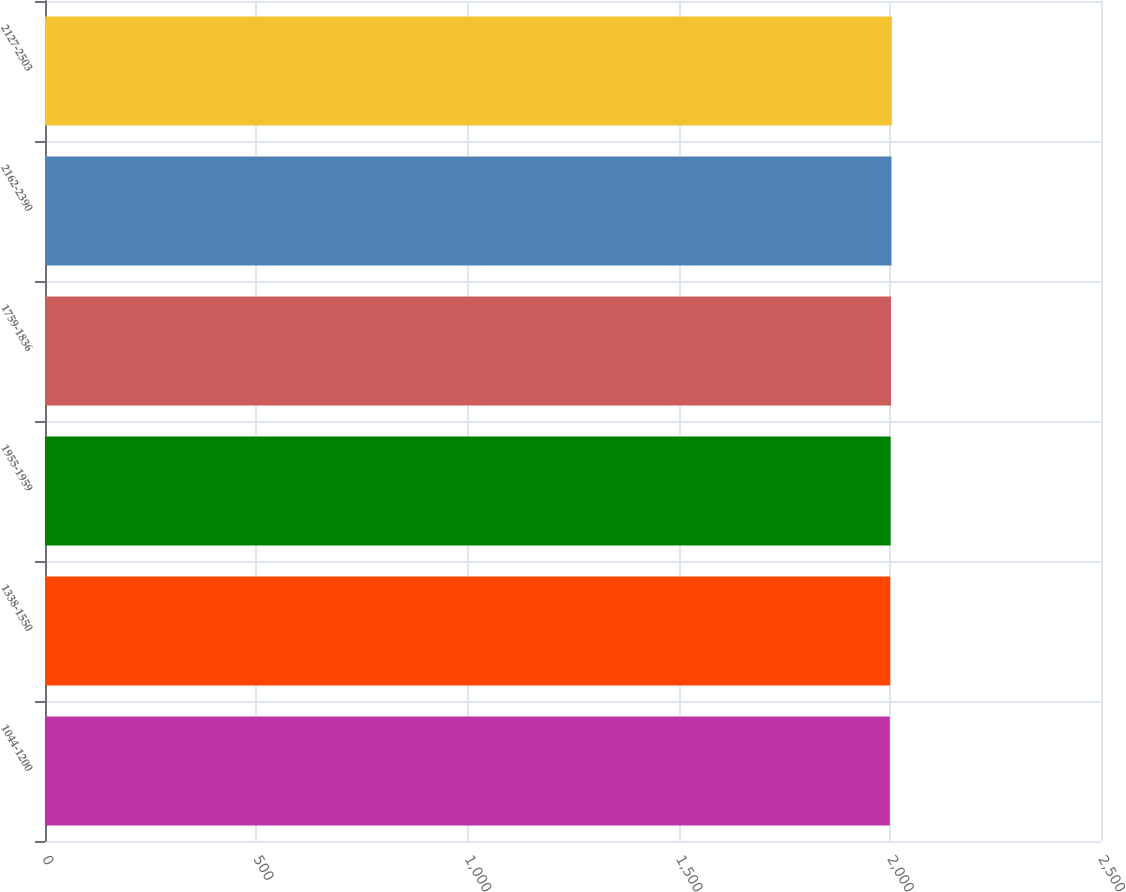Convert chart. <chart><loc_0><loc_0><loc_500><loc_500><bar_chart><fcel>1044-1200<fcel>1338-1550<fcel>1955-1959<fcel>1759-1836<fcel>2162-2390<fcel>2127-2503<nl><fcel>2000<fcel>2001<fcel>2002<fcel>2003<fcel>2004<fcel>2005<nl></chart> 